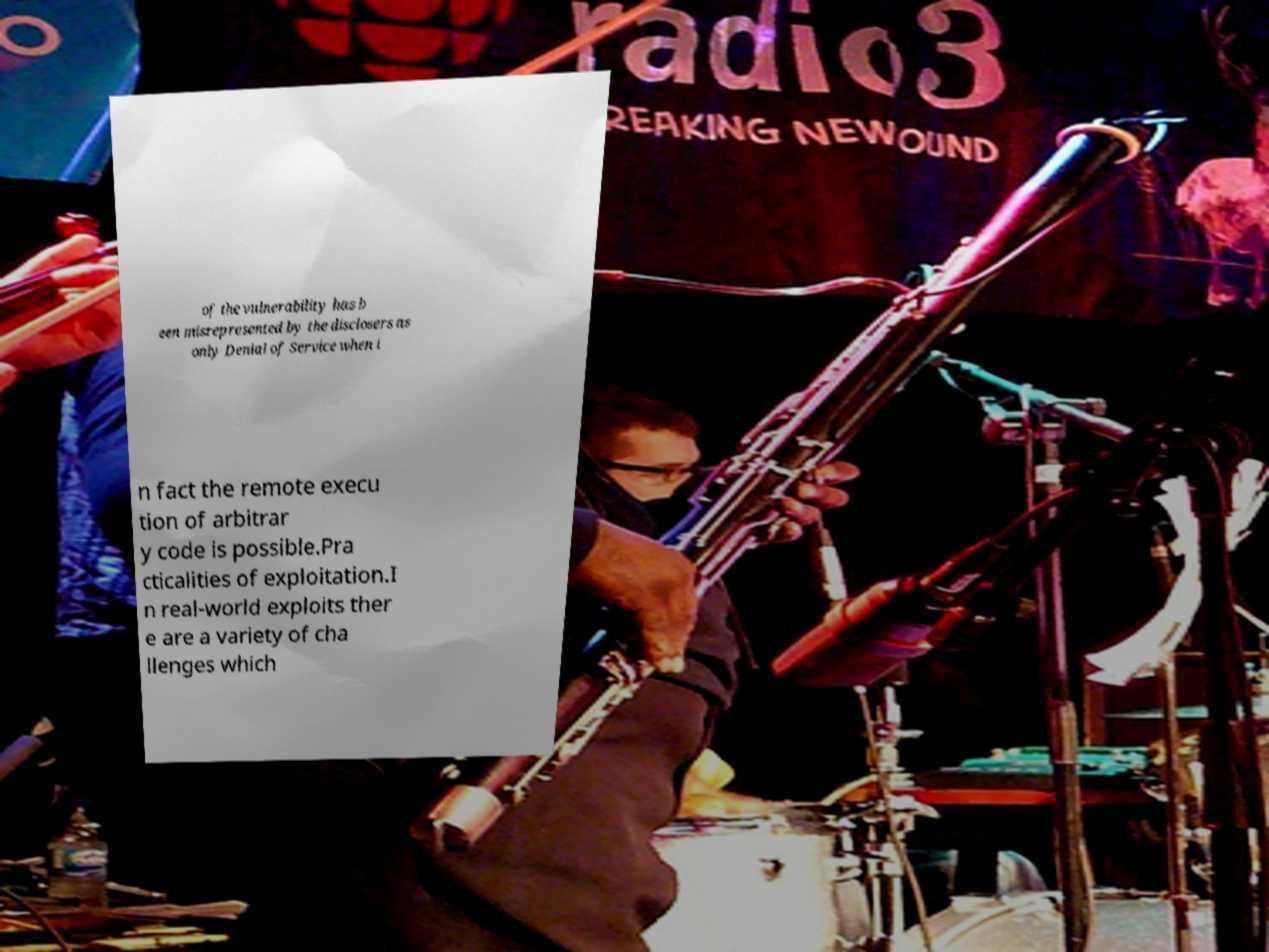There's text embedded in this image that I need extracted. Can you transcribe it verbatim? of the vulnerability has b een misrepresented by the disclosers as only Denial of Service when i n fact the remote execu tion of arbitrar y code is possible.Pra cticalities of exploitation.I n real-world exploits ther e are a variety of cha llenges which 